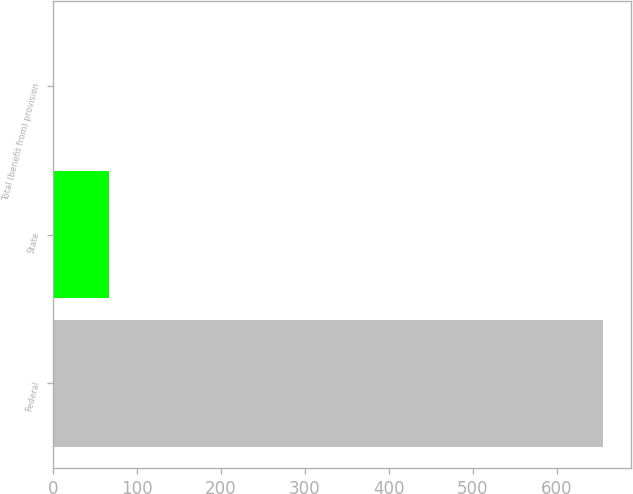Convert chart to OTSL. <chart><loc_0><loc_0><loc_500><loc_500><bar_chart><fcel>Federal<fcel>State<fcel>Total (benefit from) provision<nl><fcel>655.1<fcel>67.13<fcel>1.8<nl></chart> 